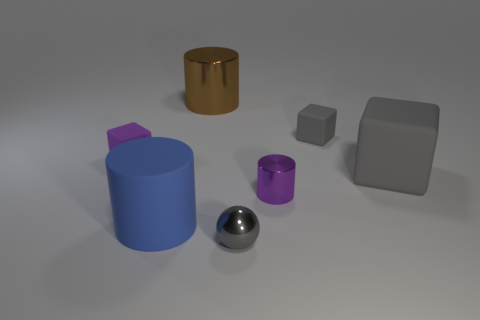The small purple object on the right side of the large brown thing that is behind the big gray matte object is what shape?
Ensure brevity in your answer.  Cylinder. What is the size of the metal thing that is behind the small rubber block to the right of the small gray thing that is in front of the big blue cylinder?
Keep it short and to the point. Large. Do the purple block and the metallic sphere have the same size?
Your answer should be very brief. Yes. How many objects are tiny metallic objects or big matte cubes?
Your answer should be compact. 3. There is a metal thing that is on the left side of the metal ball to the left of the purple metal cylinder; how big is it?
Make the answer very short. Large. How big is the purple rubber cube?
Ensure brevity in your answer.  Small. The metal thing that is behind the big blue object and in front of the large brown cylinder has what shape?
Provide a short and direct response. Cylinder. The rubber object that is the same shape as the purple metallic thing is what color?
Offer a terse response. Blue. What number of things are gray rubber blocks that are in front of the purple rubber cube or objects that are left of the large metallic object?
Offer a terse response. 3. What is the shape of the tiny purple shiny thing?
Offer a very short reply. Cylinder. 